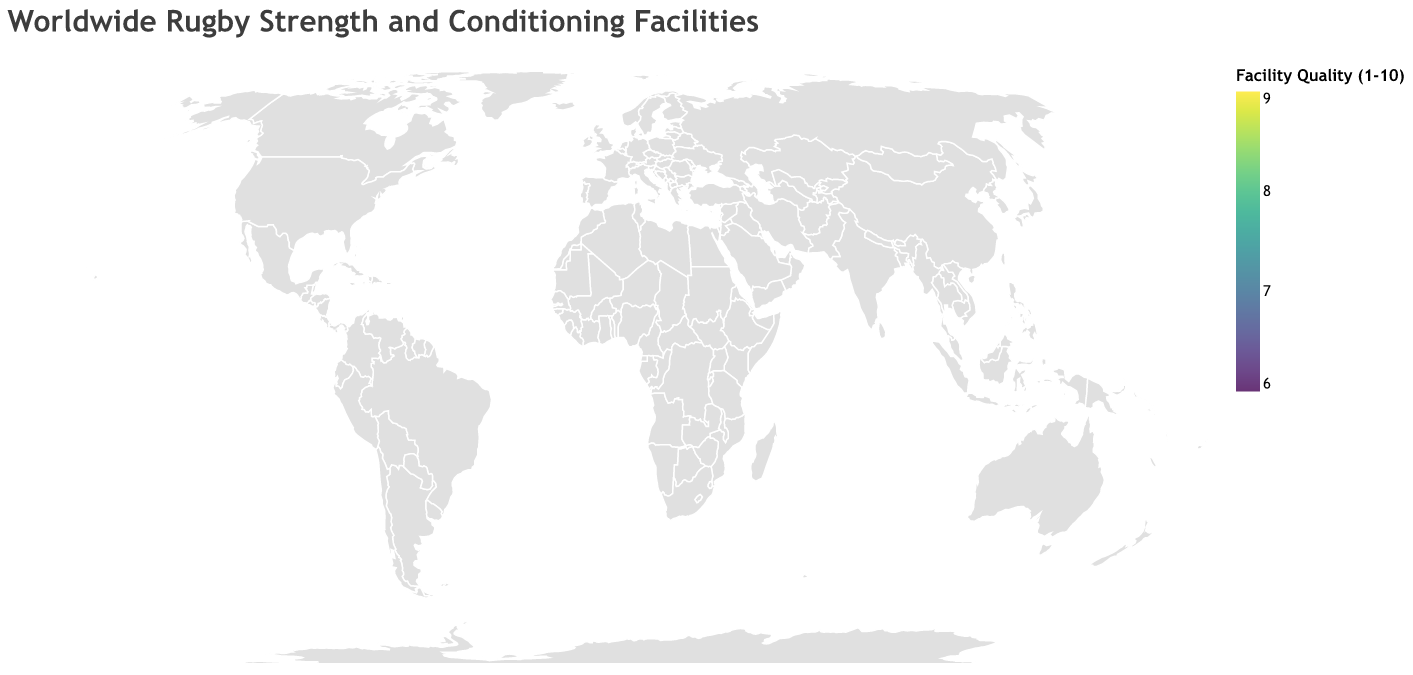What's the highest quality rating for any facility on the map? Look for the facility with the largest circle and the darkest color on the map. The quality rating is indicated by size and color. Refer to the legend to determine the exact rating. The highest quality rating visible is 9.
Answer: 9 Which country has the facility with the highest quality rating? Identify the facility with the highest quality rating (9) and find its country. From the tooltip or data points, Auckland Rugby Performance Centre in New Zealand and Leinster Rugby High Performance Centre in Ireland both have a rating of 9.
Answer: New Zealand and Ireland How many facilities have a quality rating of 7? Count the number of circles with the color corresponding to the rating of 7 as per the legend. Cross-check with tooltip data for confirmation. There are 5 facilities with a quality rating of 7.
Answer: 5 What is the specialization of the facility in Dublin? Hover over the circle located in Dublin to check its tooltip, which shows the specialization field. The specialization for Dublin is "Rugby strength and power."
Answer: Rugby strength and power Which facility is located furthest south? Compare the latitudes of all facilities and identify the one with the smallest (most negative) latitude. Suva in Fiji has the smallest latitude of -18.1416.
Answer: Fiji Rugby High Performance Unit Compare the quality ratings of facilities in the Southern Hemisphere versus the Northern Hemisphere. Which hemisphere has higher average quality? List the facilities in each hemisphere. Calculate their average quality rating: Southern Hemisphere (New Zealand, South Africa, Australia, Argentina, Fiji) and Northern Hemisphere (England, Ireland, France, Japan, Wales, Scotland, Italy). Calculate respective averages and compare. Southern Hemisphere: (9+7+8+7+6)/5 = 7.4; Northern Hemisphere: (8+9+8+7+8+7+6)/7 = 7.57.
Answer: Northern Hemisphere Which city hosts a facility specialized in 'Prop-focused conditioning'? Look for the facility with the 'Prop-focused conditioning' specialization in the tooltip data. The facility in Bath, England, specializes in Prop-focused conditioning.
Answer: Bath Identify the specialization of the facility in Cape Town and its quality rating. Hover over the circle in Cape Town to display its tooltip, which contains both the specialization and quality rating. The specialization in Cape Town is "Scrum machine training" with a quality rating of 7.
Answer: Scrum machine training, 7 